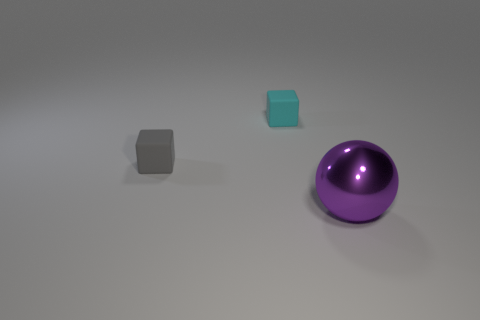Add 3 tiny gray things. How many objects exist? 6 Subtract all balls. How many objects are left? 2 Subtract 0 green balls. How many objects are left? 3 Subtract all yellow rubber objects. Subtract all large purple spheres. How many objects are left? 2 Add 2 tiny gray matte blocks. How many tiny gray matte blocks are left? 3 Add 1 purple balls. How many purple balls exist? 2 